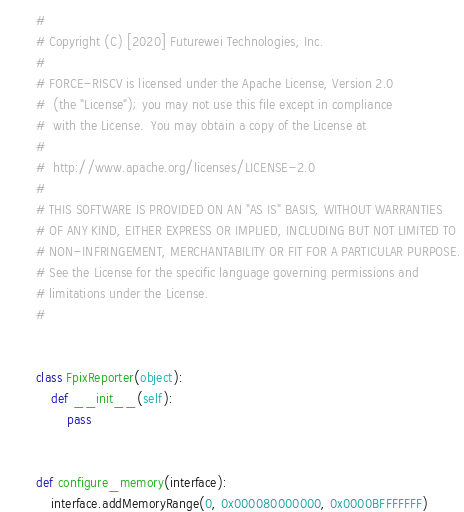<code> <loc_0><loc_0><loc_500><loc_500><_Python_>#
# Copyright (C) [2020] Futurewei Technologies, Inc.
#
# FORCE-RISCV is licensed under the Apache License, Version 2.0
#  (the "License"); you may not use this file except in compliance
#  with the License.  You may obtain a copy of the License at
#
#  http://www.apache.org/licenses/LICENSE-2.0
#
# THIS SOFTWARE IS PROVIDED ON AN "AS IS" BASIS, WITHOUT WARRANTIES
# OF ANY KIND, EITHER EXPRESS OR IMPLIED, INCLUDING BUT NOT LIMITED TO
# NON-INFRINGEMENT, MERCHANTABILITY OR FIT FOR A PARTICULAR PURPOSE.
# See the License for the specific language governing permissions and
# limitations under the License.
#


class FpixReporter(object):
    def __init__(self):
        pass


def configure_memory(interface):
    interface.addMemoryRange(0, 0x000080000000, 0x0000BFFFFFFF)
</code> 